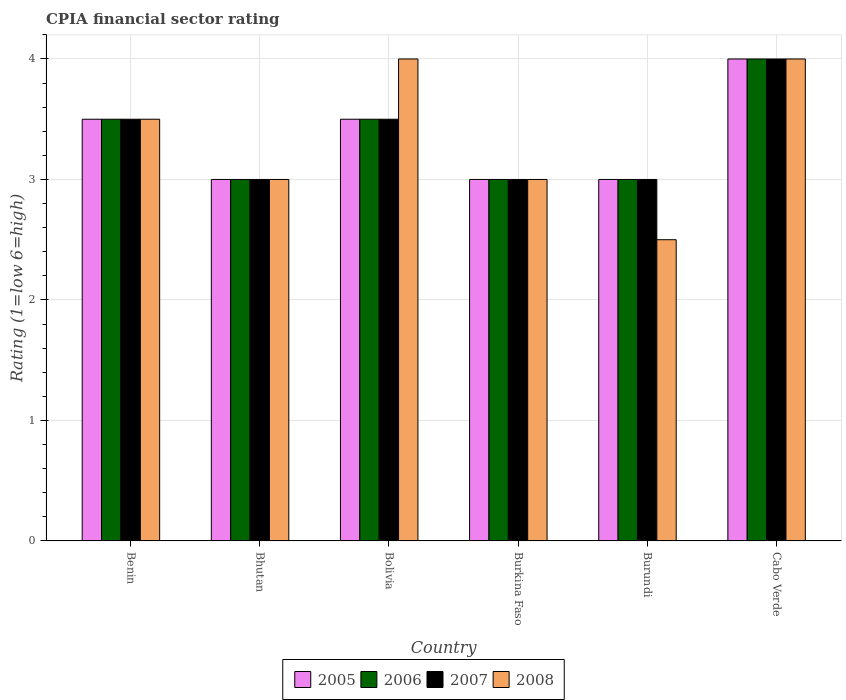How many different coloured bars are there?
Provide a succinct answer. 4. How many groups of bars are there?
Your response must be concise. 6. Are the number of bars on each tick of the X-axis equal?
Offer a very short reply. Yes. What is the label of the 4th group of bars from the left?
Your response must be concise. Burkina Faso. Across all countries, what is the maximum CPIA rating in 2008?
Make the answer very short. 4. Across all countries, what is the minimum CPIA rating in 2007?
Provide a short and direct response. 3. In which country was the CPIA rating in 2008 maximum?
Offer a terse response. Bolivia. In which country was the CPIA rating in 2006 minimum?
Provide a succinct answer. Bhutan. What is the total CPIA rating in 2005 in the graph?
Your answer should be very brief. 20. What is the difference between the CPIA rating in 2007 in Burkina Faso and that in Cabo Verde?
Your response must be concise. -1. What is the average CPIA rating in 2007 per country?
Provide a succinct answer. 3.33. In how many countries, is the CPIA rating in 2008 greater than 1.2?
Your answer should be compact. 6. What is the ratio of the CPIA rating in 2005 in Burkina Faso to that in Burundi?
Make the answer very short. 1. Is the difference between the CPIA rating in 2005 in Bhutan and Burkina Faso greater than the difference between the CPIA rating in 2006 in Bhutan and Burkina Faso?
Offer a terse response. No. What is the difference between the highest and the lowest CPIA rating in 2005?
Provide a succinct answer. 1. Is the sum of the CPIA rating in 2008 in Bolivia and Cabo Verde greater than the maximum CPIA rating in 2005 across all countries?
Provide a short and direct response. Yes. What does the 2nd bar from the right in Bhutan represents?
Keep it short and to the point. 2007. Is it the case that in every country, the sum of the CPIA rating in 2006 and CPIA rating in 2008 is greater than the CPIA rating in 2007?
Provide a short and direct response. Yes. How many countries are there in the graph?
Make the answer very short. 6. Does the graph contain grids?
Provide a succinct answer. Yes. Where does the legend appear in the graph?
Your response must be concise. Bottom center. How are the legend labels stacked?
Your answer should be compact. Horizontal. What is the title of the graph?
Provide a succinct answer. CPIA financial sector rating. What is the Rating (1=low 6=high) in 2005 in Benin?
Ensure brevity in your answer.  3.5. What is the Rating (1=low 6=high) in 2006 in Benin?
Your answer should be compact. 3.5. What is the Rating (1=low 6=high) in 2006 in Bhutan?
Offer a terse response. 3. What is the Rating (1=low 6=high) in 2007 in Bolivia?
Give a very brief answer. 3.5. What is the Rating (1=low 6=high) of 2006 in Burkina Faso?
Offer a terse response. 3. What is the Rating (1=low 6=high) of 2008 in Burkina Faso?
Your answer should be compact. 3. What is the Rating (1=low 6=high) of 2006 in Burundi?
Offer a very short reply. 3. What is the Rating (1=low 6=high) in 2007 in Burundi?
Provide a short and direct response. 3. What is the Rating (1=low 6=high) of 2005 in Cabo Verde?
Ensure brevity in your answer.  4. What is the Rating (1=low 6=high) of 2006 in Cabo Verde?
Ensure brevity in your answer.  4. What is the Rating (1=low 6=high) in 2007 in Cabo Verde?
Provide a succinct answer. 4. What is the Rating (1=low 6=high) in 2008 in Cabo Verde?
Make the answer very short. 4. Across all countries, what is the maximum Rating (1=low 6=high) of 2006?
Offer a terse response. 4. Across all countries, what is the maximum Rating (1=low 6=high) in 2007?
Your response must be concise. 4. Across all countries, what is the maximum Rating (1=low 6=high) in 2008?
Give a very brief answer. 4. Across all countries, what is the minimum Rating (1=low 6=high) of 2006?
Your answer should be compact. 3. Across all countries, what is the minimum Rating (1=low 6=high) in 2007?
Your answer should be compact. 3. What is the total Rating (1=low 6=high) in 2007 in the graph?
Provide a succinct answer. 20. What is the difference between the Rating (1=low 6=high) in 2005 in Benin and that in Bhutan?
Your response must be concise. 0.5. What is the difference between the Rating (1=low 6=high) in 2006 in Benin and that in Bhutan?
Offer a terse response. 0.5. What is the difference between the Rating (1=low 6=high) of 2008 in Benin and that in Bhutan?
Your answer should be very brief. 0.5. What is the difference between the Rating (1=low 6=high) in 2005 in Benin and that in Bolivia?
Give a very brief answer. 0. What is the difference between the Rating (1=low 6=high) in 2006 in Benin and that in Bolivia?
Your answer should be compact. 0. What is the difference between the Rating (1=low 6=high) in 2008 in Benin and that in Bolivia?
Ensure brevity in your answer.  -0.5. What is the difference between the Rating (1=low 6=high) in 2005 in Benin and that in Burkina Faso?
Your response must be concise. 0.5. What is the difference between the Rating (1=low 6=high) of 2007 in Benin and that in Burkina Faso?
Provide a succinct answer. 0.5. What is the difference between the Rating (1=low 6=high) in 2008 in Benin and that in Burkina Faso?
Keep it short and to the point. 0.5. What is the difference between the Rating (1=low 6=high) of 2006 in Benin and that in Burundi?
Give a very brief answer. 0.5. What is the difference between the Rating (1=low 6=high) in 2007 in Benin and that in Burundi?
Provide a succinct answer. 0.5. What is the difference between the Rating (1=low 6=high) of 2005 in Benin and that in Cabo Verde?
Your response must be concise. -0.5. What is the difference between the Rating (1=low 6=high) of 2006 in Benin and that in Cabo Verde?
Give a very brief answer. -0.5. What is the difference between the Rating (1=low 6=high) in 2007 in Benin and that in Cabo Verde?
Keep it short and to the point. -0.5. What is the difference between the Rating (1=low 6=high) of 2008 in Benin and that in Cabo Verde?
Give a very brief answer. -0.5. What is the difference between the Rating (1=low 6=high) in 2007 in Bhutan and that in Bolivia?
Keep it short and to the point. -0.5. What is the difference between the Rating (1=low 6=high) in 2005 in Bhutan and that in Burkina Faso?
Make the answer very short. 0. What is the difference between the Rating (1=low 6=high) of 2007 in Bhutan and that in Burkina Faso?
Your answer should be compact. 0. What is the difference between the Rating (1=low 6=high) of 2005 in Bhutan and that in Burundi?
Offer a terse response. 0. What is the difference between the Rating (1=low 6=high) of 2007 in Bhutan and that in Burundi?
Keep it short and to the point. 0. What is the difference between the Rating (1=low 6=high) in 2008 in Bhutan and that in Burundi?
Offer a terse response. 0.5. What is the difference between the Rating (1=low 6=high) in 2005 in Bhutan and that in Cabo Verde?
Your answer should be compact. -1. What is the difference between the Rating (1=low 6=high) of 2008 in Bhutan and that in Cabo Verde?
Keep it short and to the point. -1. What is the difference between the Rating (1=low 6=high) in 2005 in Bolivia and that in Burkina Faso?
Provide a short and direct response. 0.5. What is the difference between the Rating (1=low 6=high) of 2006 in Bolivia and that in Burundi?
Keep it short and to the point. 0.5. What is the difference between the Rating (1=low 6=high) of 2007 in Bolivia and that in Burundi?
Keep it short and to the point. 0.5. What is the difference between the Rating (1=low 6=high) in 2005 in Bolivia and that in Cabo Verde?
Provide a short and direct response. -0.5. What is the difference between the Rating (1=low 6=high) in 2007 in Bolivia and that in Cabo Verde?
Keep it short and to the point. -0.5. What is the difference between the Rating (1=low 6=high) of 2008 in Bolivia and that in Cabo Verde?
Make the answer very short. 0. What is the difference between the Rating (1=low 6=high) of 2006 in Burkina Faso and that in Burundi?
Offer a very short reply. 0. What is the difference between the Rating (1=low 6=high) of 2007 in Burkina Faso and that in Burundi?
Your response must be concise. 0. What is the difference between the Rating (1=low 6=high) in 2008 in Burkina Faso and that in Cabo Verde?
Keep it short and to the point. -1. What is the difference between the Rating (1=low 6=high) in 2006 in Burundi and that in Cabo Verde?
Your answer should be compact. -1. What is the difference between the Rating (1=low 6=high) in 2008 in Burundi and that in Cabo Verde?
Your response must be concise. -1.5. What is the difference between the Rating (1=low 6=high) of 2005 in Benin and the Rating (1=low 6=high) of 2007 in Bhutan?
Keep it short and to the point. 0.5. What is the difference between the Rating (1=low 6=high) in 2006 in Benin and the Rating (1=low 6=high) in 2007 in Bhutan?
Your answer should be compact. 0.5. What is the difference between the Rating (1=low 6=high) of 2005 in Benin and the Rating (1=low 6=high) of 2006 in Bolivia?
Give a very brief answer. 0. What is the difference between the Rating (1=low 6=high) in 2005 in Benin and the Rating (1=low 6=high) in 2007 in Bolivia?
Your answer should be very brief. 0. What is the difference between the Rating (1=low 6=high) in 2006 in Benin and the Rating (1=low 6=high) in 2008 in Bolivia?
Provide a succinct answer. -0.5. What is the difference between the Rating (1=low 6=high) of 2007 in Benin and the Rating (1=low 6=high) of 2008 in Bolivia?
Your answer should be very brief. -0.5. What is the difference between the Rating (1=low 6=high) of 2005 in Benin and the Rating (1=low 6=high) of 2007 in Burundi?
Keep it short and to the point. 0.5. What is the difference between the Rating (1=low 6=high) in 2006 in Benin and the Rating (1=low 6=high) in 2007 in Burundi?
Keep it short and to the point. 0.5. What is the difference between the Rating (1=low 6=high) in 2006 in Benin and the Rating (1=low 6=high) in 2008 in Burundi?
Ensure brevity in your answer.  1. What is the difference between the Rating (1=low 6=high) of 2007 in Benin and the Rating (1=low 6=high) of 2008 in Burundi?
Make the answer very short. 1. What is the difference between the Rating (1=low 6=high) of 2005 in Benin and the Rating (1=low 6=high) of 2006 in Cabo Verde?
Give a very brief answer. -0.5. What is the difference between the Rating (1=low 6=high) of 2005 in Benin and the Rating (1=low 6=high) of 2008 in Cabo Verde?
Give a very brief answer. -0.5. What is the difference between the Rating (1=low 6=high) of 2006 in Benin and the Rating (1=low 6=high) of 2007 in Cabo Verde?
Provide a short and direct response. -0.5. What is the difference between the Rating (1=low 6=high) of 2006 in Benin and the Rating (1=low 6=high) of 2008 in Cabo Verde?
Make the answer very short. -0.5. What is the difference between the Rating (1=low 6=high) of 2007 in Benin and the Rating (1=low 6=high) of 2008 in Cabo Verde?
Offer a very short reply. -0.5. What is the difference between the Rating (1=low 6=high) of 2005 in Bhutan and the Rating (1=low 6=high) of 2006 in Bolivia?
Your answer should be compact. -0.5. What is the difference between the Rating (1=low 6=high) of 2006 in Bhutan and the Rating (1=low 6=high) of 2007 in Bolivia?
Provide a short and direct response. -0.5. What is the difference between the Rating (1=low 6=high) in 2006 in Bhutan and the Rating (1=low 6=high) in 2008 in Bolivia?
Provide a succinct answer. -1. What is the difference between the Rating (1=low 6=high) in 2006 in Bhutan and the Rating (1=low 6=high) in 2007 in Burkina Faso?
Offer a very short reply. 0. What is the difference between the Rating (1=low 6=high) of 2007 in Bhutan and the Rating (1=low 6=high) of 2008 in Burkina Faso?
Offer a terse response. 0. What is the difference between the Rating (1=low 6=high) of 2005 in Bhutan and the Rating (1=low 6=high) of 2007 in Burundi?
Give a very brief answer. 0. What is the difference between the Rating (1=low 6=high) in 2006 in Bhutan and the Rating (1=low 6=high) in 2008 in Cabo Verde?
Your answer should be compact. -1. What is the difference between the Rating (1=low 6=high) of 2005 in Bolivia and the Rating (1=low 6=high) of 2006 in Burkina Faso?
Offer a very short reply. 0.5. What is the difference between the Rating (1=low 6=high) of 2005 in Bolivia and the Rating (1=low 6=high) of 2008 in Burkina Faso?
Your answer should be compact. 0.5. What is the difference between the Rating (1=low 6=high) of 2005 in Bolivia and the Rating (1=low 6=high) of 2007 in Burundi?
Make the answer very short. 0.5. What is the difference between the Rating (1=low 6=high) of 2006 in Bolivia and the Rating (1=low 6=high) of 2007 in Burundi?
Give a very brief answer. 0.5. What is the difference between the Rating (1=low 6=high) of 2006 in Bolivia and the Rating (1=low 6=high) of 2008 in Burundi?
Keep it short and to the point. 1. What is the difference between the Rating (1=low 6=high) of 2007 in Bolivia and the Rating (1=low 6=high) of 2008 in Burundi?
Provide a succinct answer. 1. What is the difference between the Rating (1=low 6=high) in 2005 in Bolivia and the Rating (1=low 6=high) in 2006 in Cabo Verde?
Make the answer very short. -0.5. What is the difference between the Rating (1=low 6=high) of 2005 in Bolivia and the Rating (1=low 6=high) of 2008 in Cabo Verde?
Offer a terse response. -0.5. What is the difference between the Rating (1=low 6=high) of 2006 in Bolivia and the Rating (1=low 6=high) of 2008 in Cabo Verde?
Offer a terse response. -0.5. What is the difference between the Rating (1=low 6=high) in 2007 in Bolivia and the Rating (1=low 6=high) in 2008 in Cabo Verde?
Make the answer very short. -0.5. What is the difference between the Rating (1=low 6=high) in 2005 in Burkina Faso and the Rating (1=low 6=high) in 2006 in Cabo Verde?
Your answer should be very brief. -1. What is the difference between the Rating (1=low 6=high) of 2005 in Burkina Faso and the Rating (1=low 6=high) of 2008 in Cabo Verde?
Make the answer very short. -1. What is the difference between the Rating (1=low 6=high) of 2006 in Burkina Faso and the Rating (1=low 6=high) of 2007 in Cabo Verde?
Offer a very short reply. -1. What is the difference between the Rating (1=low 6=high) in 2005 in Burundi and the Rating (1=low 6=high) in 2006 in Cabo Verde?
Ensure brevity in your answer.  -1. What is the difference between the Rating (1=low 6=high) in 2005 in Burundi and the Rating (1=low 6=high) in 2007 in Cabo Verde?
Make the answer very short. -1. What is the difference between the Rating (1=low 6=high) in 2005 in Burundi and the Rating (1=low 6=high) in 2008 in Cabo Verde?
Your answer should be very brief. -1. What is the difference between the Rating (1=low 6=high) of 2006 in Burundi and the Rating (1=low 6=high) of 2007 in Cabo Verde?
Your answer should be compact. -1. What is the average Rating (1=low 6=high) in 2005 per country?
Your answer should be very brief. 3.33. What is the average Rating (1=low 6=high) of 2006 per country?
Ensure brevity in your answer.  3.33. What is the difference between the Rating (1=low 6=high) in 2005 and Rating (1=low 6=high) in 2008 in Benin?
Ensure brevity in your answer.  0. What is the difference between the Rating (1=low 6=high) of 2006 and Rating (1=low 6=high) of 2008 in Benin?
Your answer should be compact. 0. What is the difference between the Rating (1=low 6=high) in 2007 and Rating (1=low 6=high) in 2008 in Benin?
Keep it short and to the point. 0. What is the difference between the Rating (1=low 6=high) of 2005 and Rating (1=low 6=high) of 2007 in Bhutan?
Your answer should be very brief. 0. What is the difference between the Rating (1=low 6=high) of 2006 and Rating (1=low 6=high) of 2007 in Bhutan?
Ensure brevity in your answer.  0. What is the difference between the Rating (1=low 6=high) of 2006 and Rating (1=low 6=high) of 2008 in Bhutan?
Offer a terse response. 0. What is the difference between the Rating (1=low 6=high) of 2007 and Rating (1=low 6=high) of 2008 in Bhutan?
Give a very brief answer. 0. What is the difference between the Rating (1=low 6=high) of 2005 and Rating (1=low 6=high) of 2006 in Bolivia?
Ensure brevity in your answer.  0. What is the difference between the Rating (1=low 6=high) of 2005 and Rating (1=low 6=high) of 2008 in Bolivia?
Your answer should be very brief. -0.5. What is the difference between the Rating (1=low 6=high) of 2005 and Rating (1=low 6=high) of 2006 in Burkina Faso?
Offer a very short reply. 0. What is the difference between the Rating (1=low 6=high) in 2005 and Rating (1=low 6=high) in 2008 in Burkina Faso?
Keep it short and to the point. 0. What is the difference between the Rating (1=low 6=high) in 2006 and Rating (1=low 6=high) in 2007 in Burkina Faso?
Give a very brief answer. 0. What is the difference between the Rating (1=low 6=high) in 2006 and Rating (1=low 6=high) in 2008 in Burkina Faso?
Provide a succinct answer. 0. What is the difference between the Rating (1=low 6=high) in 2007 and Rating (1=low 6=high) in 2008 in Burkina Faso?
Provide a short and direct response. 0. What is the difference between the Rating (1=low 6=high) of 2005 and Rating (1=low 6=high) of 2006 in Burundi?
Keep it short and to the point. 0. What is the difference between the Rating (1=low 6=high) in 2005 and Rating (1=low 6=high) in 2008 in Burundi?
Provide a short and direct response. 0.5. What is the difference between the Rating (1=low 6=high) of 2007 and Rating (1=low 6=high) of 2008 in Burundi?
Provide a succinct answer. 0.5. What is the difference between the Rating (1=low 6=high) in 2005 and Rating (1=low 6=high) in 2006 in Cabo Verde?
Make the answer very short. 0. What is the difference between the Rating (1=low 6=high) in 2005 and Rating (1=low 6=high) in 2007 in Cabo Verde?
Keep it short and to the point. 0. What is the difference between the Rating (1=low 6=high) in 2006 and Rating (1=low 6=high) in 2008 in Cabo Verde?
Provide a short and direct response. 0. What is the ratio of the Rating (1=low 6=high) of 2006 in Benin to that in Bhutan?
Offer a terse response. 1.17. What is the ratio of the Rating (1=low 6=high) in 2008 in Benin to that in Bhutan?
Keep it short and to the point. 1.17. What is the ratio of the Rating (1=low 6=high) in 2006 in Benin to that in Bolivia?
Ensure brevity in your answer.  1. What is the ratio of the Rating (1=low 6=high) in 2007 in Benin to that in Bolivia?
Make the answer very short. 1. What is the ratio of the Rating (1=low 6=high) of 2008 in Benin to that in Bolivia?
Give a very brief answer. 0.88. What is the ratio of the Rating (1=low 6=high) in 2005 in Benin to that in Burkina Faso?
Your answer should be compact. 1.17. What is the ratio of the Rating (1=low 6=high) of 2007 in Benin to that in Burkina Faso?
Keep it short and to the point. 1.17. What is the ratio of the Rating (1=low 6=high) in 2006 in Benin to that in Burundi?
Your answer should be very brief. 1.17. What is the ratio of the Rating (1=low 6=high) of 2007 in Benin to that in Burundi?
Make the answer very short. 1.17. What is the ratio of the Rating (1=low 6=high) of 2005 in Benin to that in Cabo Verde?
Offer a very short reply. 0.88. What is the ratio of the Rating (1=low 6=high) of 2006 in Benin to that in Cabo Verde?
Your answer should be compact. 0.88. What is the ratio of the Rating (1=low 6=high) of 2007 in Benin to that in Cabo Verde?
Provide a succinct answer. 0.88. What is the ratio of the Rating (1=low 6=high) in 2007 in Bhutan to that in Bolivia?
Ensure brevity in your answer.  0.86. What is the ratio of the Rating (1=low 6=high) in 2005 in Bhutan to that in Burkina Faso?
Your response must be concise. 1. What is the ratio of the Rating (1=low 6=high) in 2006 in Bhutan to that in Burkina Faso?
Offer a terse response. 1. What is the ratio of the Rating (1=low 6=high) of 2007 in Bhutan to that in Burundi?
Offer a terse response. 1. What is the ratio of the Rating (1=low 6=high) of 2005 in Bhutan to that in Cabo Verde?
Offer a terse response. 0.75. What is the ratio of the Rating (1=low 6=high) of 2005 in Bolivia to that in Burkina Faso?
Give a very brief answer. 1.17. What is the ratio of the Rating (1=low 6=high) of 2007 in Bolivia to that in Burkina Faso?
Your response must be concise. 1.17. What is the ratio of the Rating (1=low 6=high) of 2008 in Bolivia to that in Burkina Faso?
Your answer should be very brief. 1.33. What is the ratio of the Rating (1=low 6=high) in 2005 in Bolivia to that in Burundi?
Your response must be concise. 1.17. What is the ratio of the Rating (1=low 6=high) of 2008 in Bolivia to that in Cabo Verde?
Give a very brief answer. 1. What is the ratio of the Rating (1=low 6=high) in 2005 in Burkina Faso to that in Burundi?
Your response must be concise. 1. What is the ratio of the Rating (1=low 6=high) in 2006 in Burkina Faso to that in Burundi?
Offer a terse response. 1. What is the ratio of the Rating (1=low 6=high) in 2005 in Burkina Faso to that in Cabo Verde?
Offer a terse response. 0.75. What is the ratio of the Rating (1=low 6=high) in 2007 in Burkina Faso to that in Cabo Verde?
Your response must be concise. 0.75. What is the ratio of the Rating (1=low 6=high) in 2008 in Burkina Faso to that in Cabo Verde?
Your response must be concise. 0.75. What is the ratio of the Rating (1=low 6=high) in 2005 in Burundi to that in Cabo Verde?
Your response must be concise. 0.75. What is the difference between the highest and the second highest Rating (1=low 6=high) in 2006?
Make the answer very short. 0.5. What is the difference between the highest and the second highest Rating (1=low 6=high) of 2007?
Offer a very short reply. 0.5. What is the difference between the highest and the lowest Rating (1=low 6=high) of 2007?
Your response must be concise. 1. 